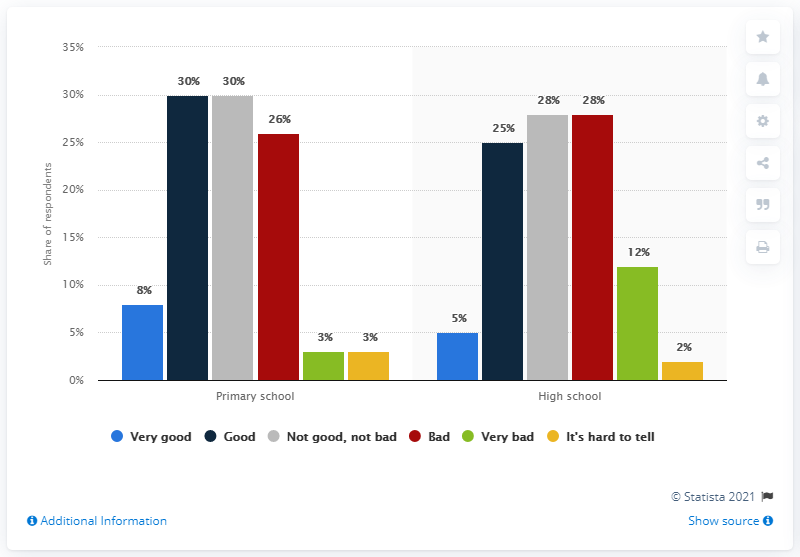Identify some key points in this picture. A survey has shown that 38% of parents of primary school children are in favor of online education. The light blue bar represents a very good attitude. 